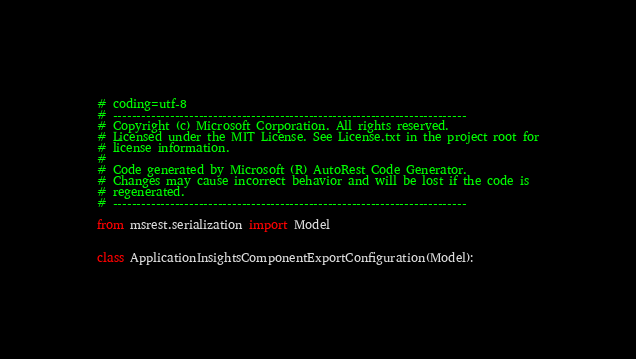<code> <loc_0><loc_0><loc_500><loc_500><_Python_># coding=utf-8
# --------------------------------------------------------------------------
# Copyright (c) Microsoft Corporation. All rights reserved.
# Licensed under the MIT License. See License.txt in the project root for
# license information.
#
# Code generated by Microsoft (R) AutoRest Code Generator.
# Changes may cause incorrect behavior and will be lost if the code is
# regenerated.
# --------------------------------------------------------------------------

from msrest.serialization import Model


class ApplicationInsightsComponentExportConfiguration(Model):</code> 